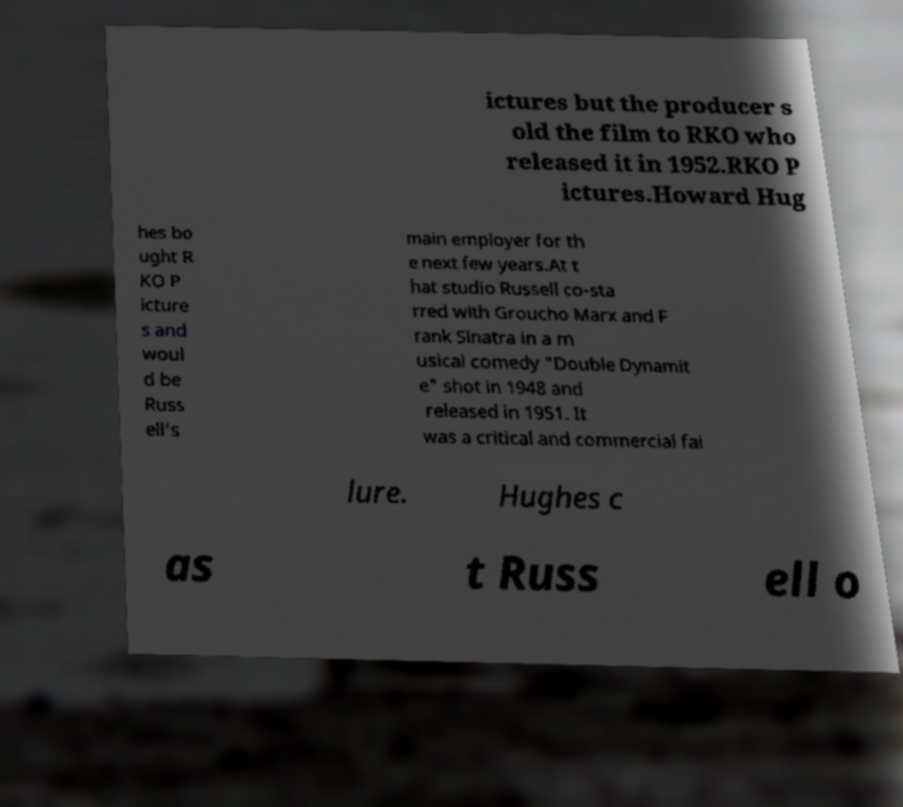Can you accurately transcribe the text from the provided image for me? ictures but the producer s old the film to RKO who released it in 1952.RKO P ictures.Howard Hug hes bo ught R KO P icture s and woul d be Russ ell's main employer for th e next few years.At t hat studio Russell co-sta rred with Groucho Marx and F rank Sinatra in a m usical comedy "Double Dynamit e" shot in 1948 and released in 1951. It was a critical and commercial fai lure. Hughes c as t Russ ell o 